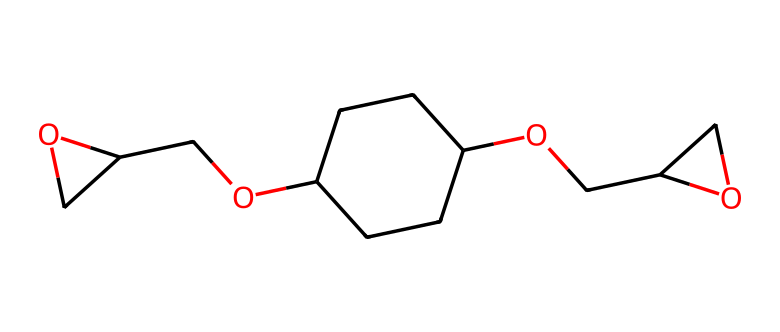What is the main functional group present in this molecule? The molecule contains -OH (alcohol) groups, which are identified as hydroxyl functional groups. Looking at the structure, I can see two -OH groups attached to different carbon atoms.
Answer: alcohol How many carbon atoms are there in this molecule? By examining the structure, I can identify the carbon atoms. Counting the carbon atoms visually, I find a total of 11 carbon atoms present in the structure.
Answer: 11 What type of bond is primarily formed between carbon atoms in this structure? The structure shows that the carbon atoms are connected primarily by single bonds, as indicated by the lack of double or triple bonds. I can confirm this by analyzing the connectivity of the carbon atoms.
Answer: single bonds Are there any cyclic structures present in this molecule? Yes, there are two cyclic structures noted in the molecule, indicated by the presence of the numbers in the SMILES which correspond to ring formations. Therefore, I can confirm that the molecule has two cyclic components.
Answer: yes What type of compound is this likely classified as? Given that this molecule features multiple hydroxyl (alcohol) groups and has a complex structure, it is likely classified as a polyol, which is a type of alcohol compound derived from sugars or used in adhesive applications.
Answer: polyol What are the implications of having hydroxyl groups in conductive adhesives? Hydroxyl groups can enhance adhesion properties of adhesives due to their ability to participate in hydrogen bonding and provide hydrophilicity. This promotes better bonding between materials, especially in electronics assembly applications.
Answer: enhance adhesion 